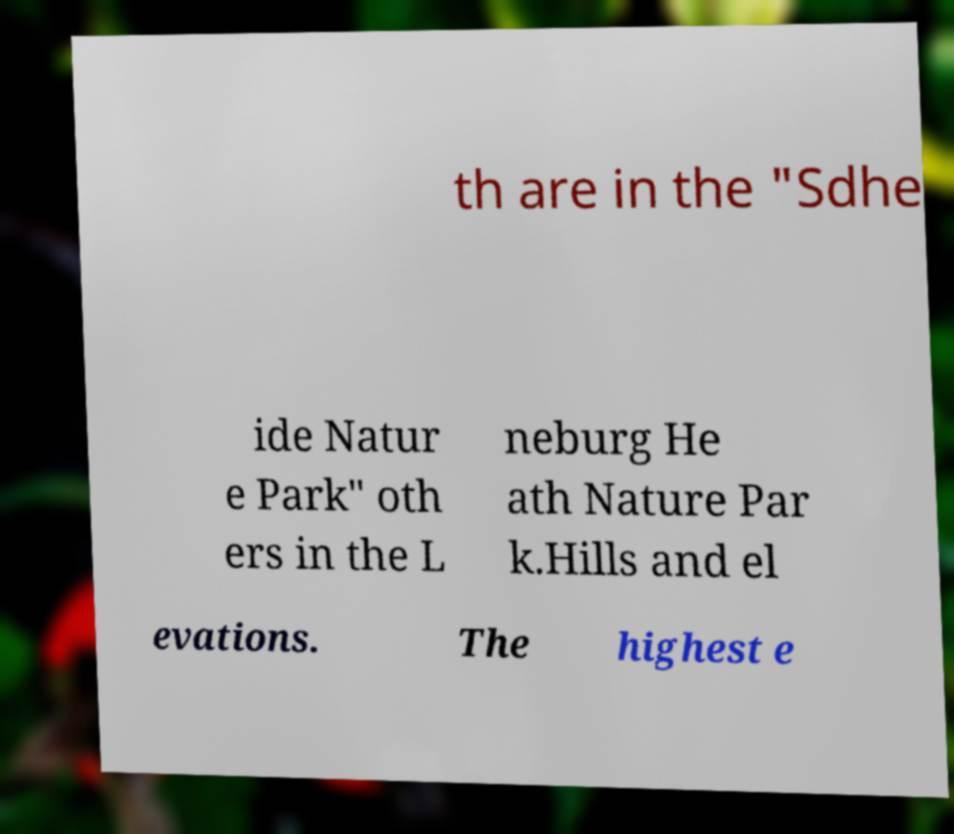Please read and relay the text visible in this image. What does it say? th are in the "Sdhe ide Natur e Park" oth ers in the L neburg He ath Nature Par k.Hills and el evations. The highest e 